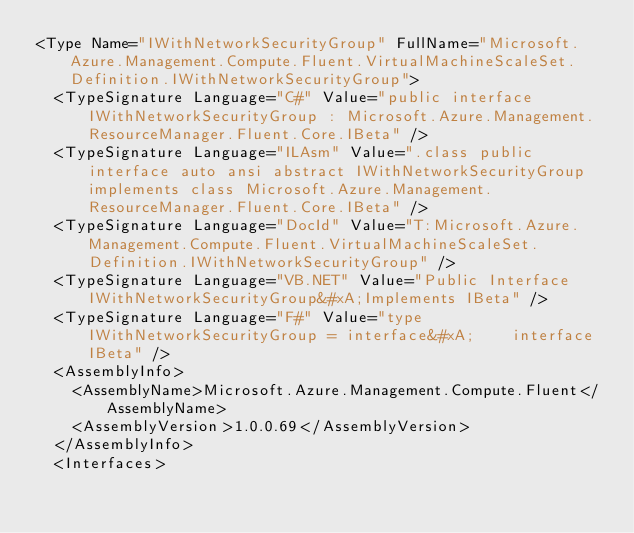<code> <loc_0><loc_0><loc_500><loc_500><_XML_><Type Name="IWithNetworkSecurityGroup" FullName="Microsoft.Azure.Management.Compute.Fluent.VirtualMachineScaleSet.Definition.IWithNetworkSecurityGroup">
  <TypeSignature Language="C#" Value="public interface IWithNetworkSecurityGroup : Microsoft.Azure.Management.ResourceManager.Fluent.Core.IBeta" />
  <TypeSignature Language="ILAsm" Value=".class public interface auto ansi abstract IWithNetworkSecurityGroup implements class Microsoft.Azure.Management.ResourceManager.Fluent.Core.IBeta" />
  <TypeSignature Language="DocId" Value="T:Microsoft.Azure.Management.Compute.Fluent.VirtualMachineScaleSet.Definition.IWithNetworkSecurityGroup" />
  <TypeSignature Language="VB.NET" Value="Public Interface IWithNetworkSecurityGroup&#xA;Implements IBeta" />
  <TypeSignature Language="F#" Value="type IWithNetworkSecurityGroup = interface&#xA;    interface IBeta" />
  <AssemblyInfo>
    <AssemblyName>Microsoft.Azure.Management.Compute.Fluent</AssemblyName>
    <AssemblyVersion>1.0.0.69</AssemblyVersion>
  </AssemblyInfo>
  <Interfaces></code> 